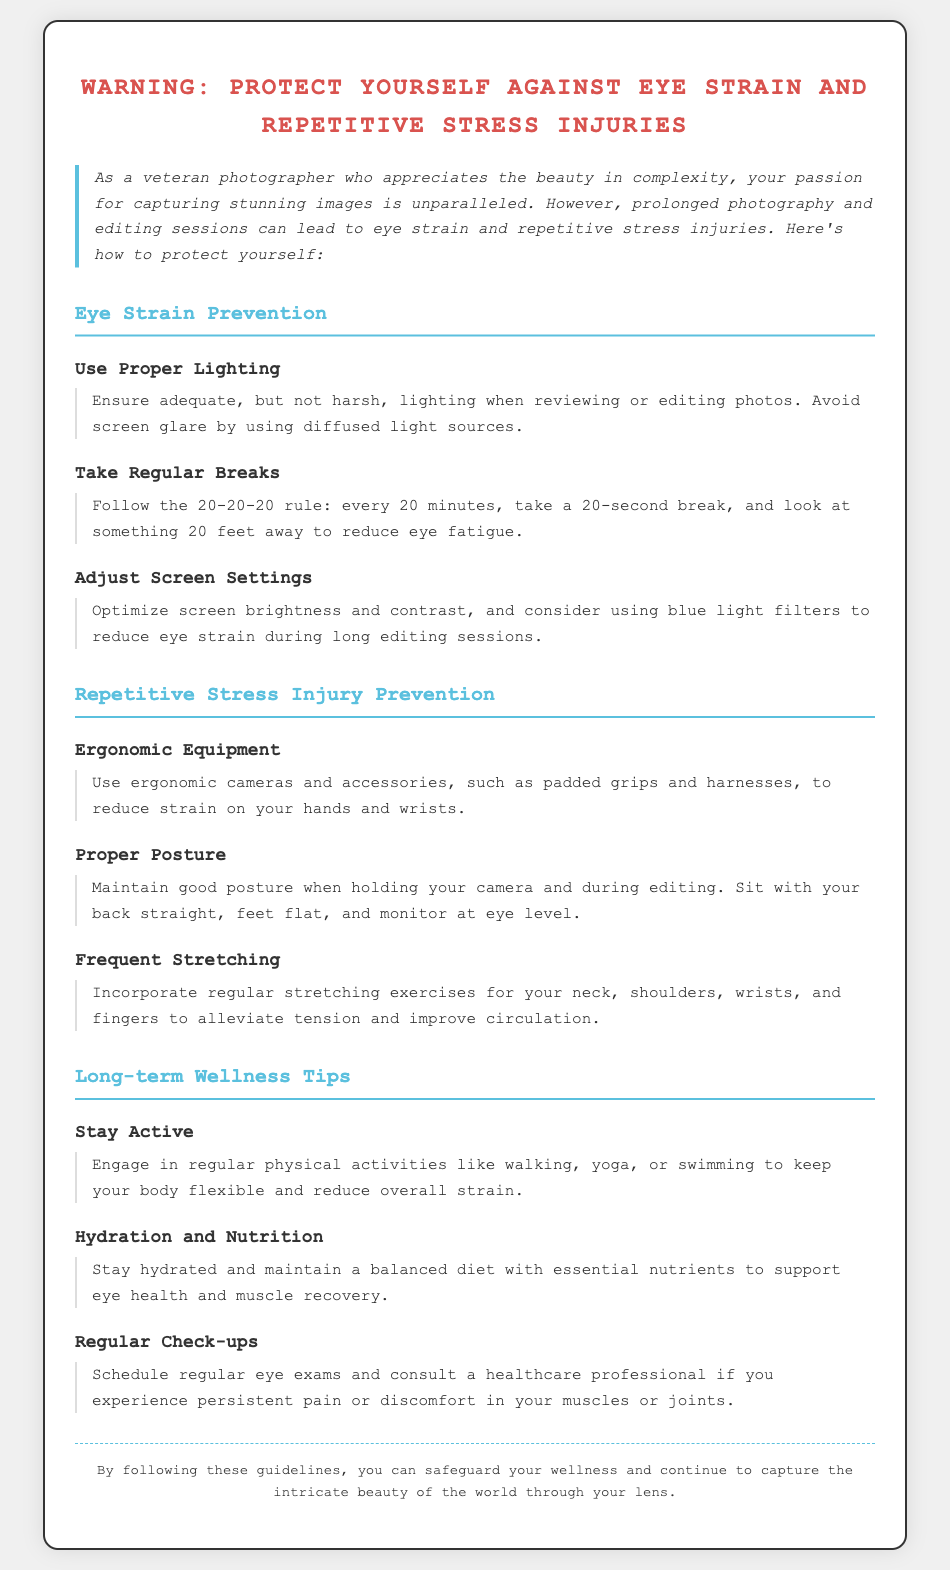What is the title of the document? The title is prominently displayed at the top of the document, indicating its purpose and subject matter.
Answer: Warning: Protect Yourself Against Eye Strain and Repetitive Stress Injuries What rule is suggested for taking breaks? The document mentions a specific guideline to help reduce eye strain during long hours of work.
Answer: 20-20-20 rule What should you do to your screen settings to reduce eye strain? The document provides a recommendation on adjusting electronic devices to ensure comfort during photography and editing.
Answer: Use blue light filters What type of exercises are recommended for relieving tension? The document lists a practical method for improving health and preventing strain injuries.
Answer: Stretching exercises What activity is suggested to stay active? It mentions a variety of physical activities beneficial for maintaining overall health and flexibility.
Answer: Yoga What type of professionals should you consult for persistent pain? The warning emphasizes the importance of professional help when experiencing discomfort related to photography work.
Answer: Healthcare professional What does the document recommend for hydration and nutrition? The document highlights a key aspect of wellness relevant to photographers' performance and health.
Answer: Balanced diet What is the color of the document's heading? The document uses a specific color to draw attention to important warnings and guidelines for photographers.
Answer: Red 